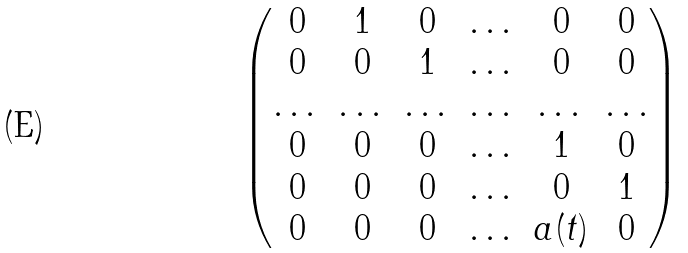<formula> <loc_0><loc_0><loc_500><loc_500>\begin{pmatrix} 0 & 1 & 0 & \dots & 0 & 0 \\ 0 & 0 & 1 & \dots & 0 & 0 \\ \dots & \dots & \dots & \dots & \dots & \dots \\ 0 & 0 & 0 & \dots & 1 & 0 \\ 0 & 0 & 0 & \dots & 0 & 1 \\ 0 & 0 & 0 & \dots & a ( t ) & 0 \\ \end{pmatrix}</formula> 